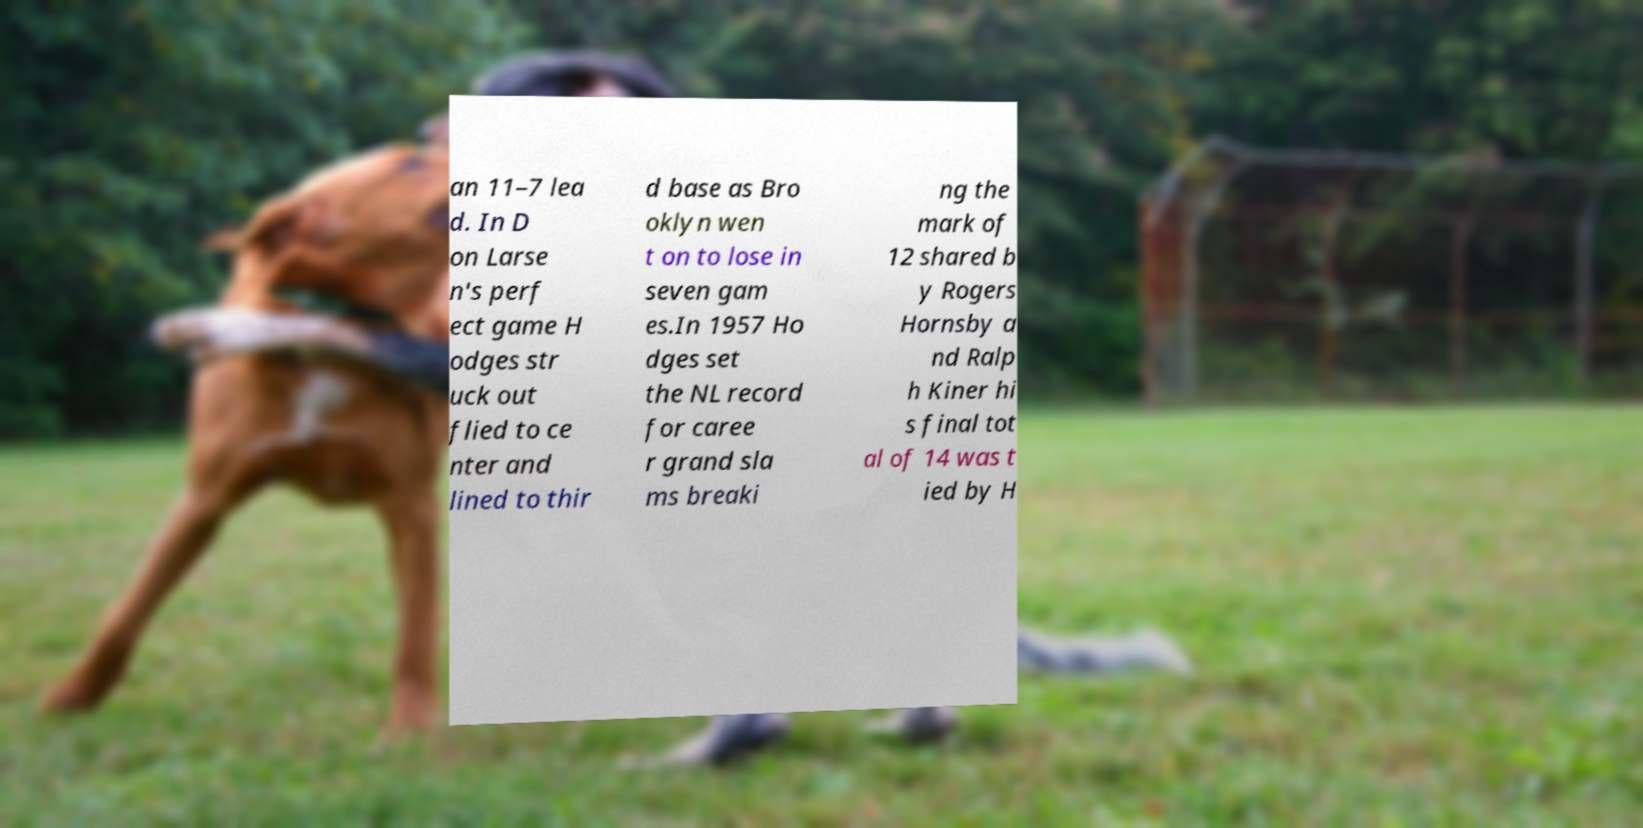Please read and relay the text visible in this image. What does it say? an 11–7 lea d. In D on Larse n's perf ect game H odges str uck out flied to ce nter and lined to thir d base as Bro oklyn wen t on to lose in seven gam es.In 1957 Ho dges set the NL record for caree r grand sla ms breaki ng the mark of 12 shared b y Rogers Hornsby a nd Ralp h Kiner hi s final tot al of 14 was t ied by H 